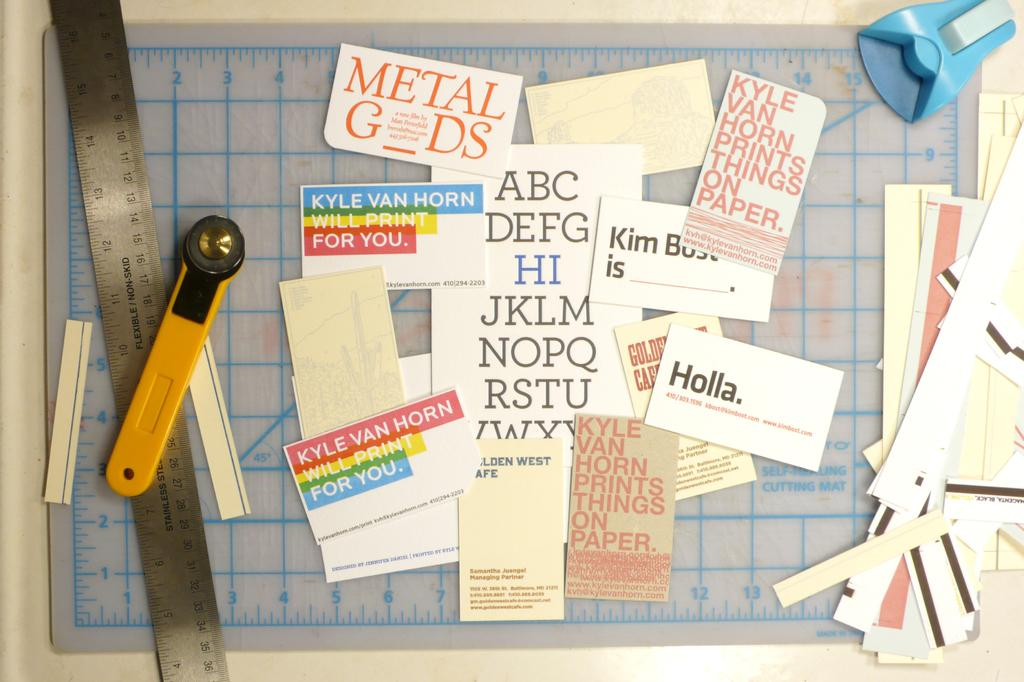<image>
Render a clear and concise summary of the photo. A paper cutting project with many pieces of paper, one reads 'Holla'. 